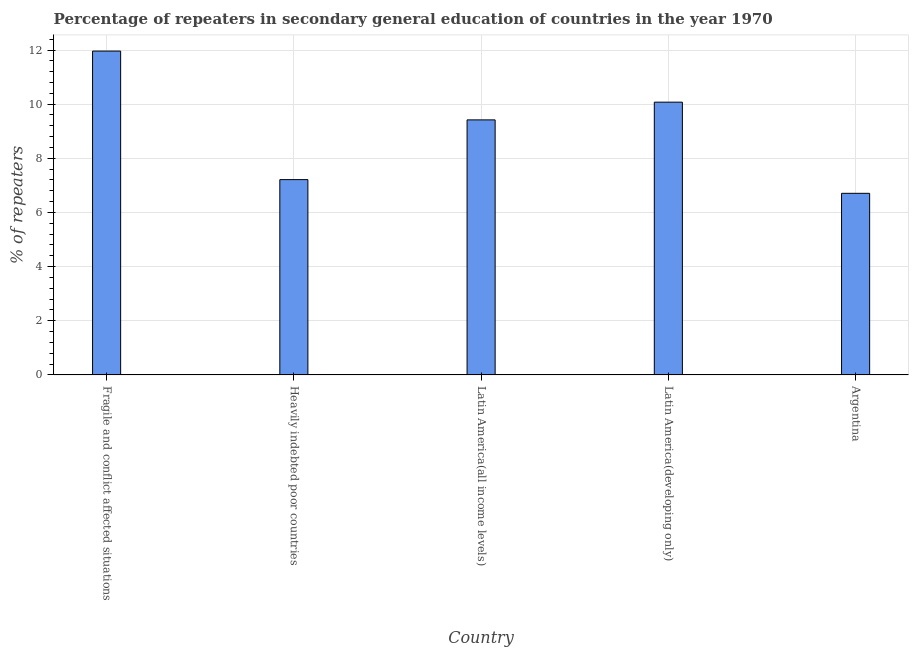Does the graph contain any zero values?
Your response must be concise. No. Does the graph contain grids?
Keep it short and to the point. Yes. What is the title of the graph?
Offer a very short reply. Percentage of repeaters in secondary general education of countries in the year 1970. What is the label or title of the X-axis?
Provide a short and direct response. Country. What is the label or title of the Y-axis?
Offer a terse response. % of repeaters. What is the percentage of repeaters in Latin America(all income levels)?
Offer a very short reply. 9.42. Across all countries, what is the maximum percentage of repeaters?
Your response must be concise. 11.96. Across all countries, what is the minimum percentage of repeaters?
Provide a short and direct response. 6.71. In which country was the percentage of repeaters maximum?
Offer a very short reply. Fragile and conflict affected situations. In which country was the percentage of repeaters minimum?
Your response must be concise. Argentina. What is the sum of the percentage of repeaters?
Your answer should be compact. 45.37. What is the difference between the percentage of repeaters in Latin America(all income levels) and Latin America(developing only)?
Provide a short and direct response. -0.65. What is the average percentage of repeaters per country?
Your answer should be very brief. 9.07. What is the median percentage of repeaters?
Your answer should be compact. 9.42. What is the ratio of the percentage of repeaters in Latin America(all income levels) to that in Latin America(developing only)?
Your answer should be compact. 0.94. Is the percentage of repeaters in Latin America(all income levels) less than that in Latin America(developing only)?
Give a very brief answer. Yes. What is the difference between the highest and the second highest percentage of repeaters?
Your answer should be very brief. 1.89. What is the difference between the highest and the lowest percentage of repeaters?
Offer a very short reply. 5.25. In how many countries, is the percentage of repeaters greater than the average percentage of repeaters taken over all countries?
Provide a short and direct response. 3. What is the difference between two consecutive major ticks on the Y-axis?
Make the answer very short. 2. Are the values on the major ticks of Y-axis written in scientific E-notation?
Ensure brevity in your answer.  No. What is the % of repeaters of Fragile and conflict affected situations?
Ensure brevity in your answer.  11.96. What is the % of repeaters of Heavily indebted poor countries?
Your answer should be very brief. 7.21. What is the % of repeaters of Latin America(all income levels)?
Ensure brevity in your answer.  9.42. What is the % of repeaters of Latin America(developing only)?
Ensure brevity in your answer.  10.07. What is the % of repeaters in Argentina?
Your answer should be compact. 6.71. What is the difference between the % of repeaters in Fragile and conflict affected situations and Heavily indebted poor countries?
Your answer should be very brief. 4.75. What is the difference between the % of repeaters in Fragile and conflict affected situations and Latin America(all income levels)?
Your answer should be very brief. 2.54. What is the difference between the % of repeaters in Fragile and conflict affected situations and Latin America(developing only)?
Offer a terse response. 1.89. What is the difference between the % of repeaters in Fragile and conflict affected situations and Argentina?
Your answer should be compact. 5.25. What is the difference between the % of repeaters in Heavily indebted poor countries and Latin America(all income levels)?
Your response must be concise. -2.21. What is the difference between the % of repeaters in Heavily indebted poor countries and Latin America(developing only)?
Make the answer very short. -2.86. What is the difference between the % of repeaters in Heavily indebted poor countries and Argentina?
Give a very brief answer. 0.51. What is the difference between the % of repeaters in Latin America(all income levels) and Latin America(developing only)?
Provide a succinct answer. -0.65. What is the difference between the % of repeaters in Latin America(all income levels) and Argentina?
Make the answer very short. 2.71. What is the difference between the % of repeaters in Latin America(developing only) and Argentina?
Keep it short and to the point. 3.37. What is the ratio of the % of repeaters in Fragile and conflict affected situations to that in Heavily indebted poor countries?
Your response must be concise. 1.66. What is the ratio of the % of repeaters in Fragile and conflict affected situations to that in Latin America(all income levels)?
Provide a short and direct response. 1.27. What is the ratio of the % of repeaters in Fragile and conflict affected situations to that in Latin America(developing only)?
Your answer should be very brief. 1.19. What is the ratio of the % of repeaters in Fragile and conflict affected situations to that in Argentina?
Ensure brevity in your answer.  1.78. What is the ratio of the % of repeaters in Heavily indebted poor countries to that in Latin America(all income levels)?
Your answer should be very brief. 0.77. What is the ratio of the % of repeaters in Heavily indebted poor countries to that in Latin America(developing only)?
Offer a terse response. 0.72. What is the ratio of the % of repeaters in Heavily indebted poor countries to that in Argentina?
Ensure brevity in your answer.  1.07. What is the ratio of the % of repeaters in Latin America(all income levels) to that in Latin America(developing only)?
Your response must be concise. 0.94. What is the ratio of the % of repeaters in Latin America(all income levels) to that in Argentina?
Offer a very short reply. 1.4. What is the ratio of the % of repeaters in Latin America(developing only) to that in Argentina?
Your answer should be very brief. 1.5. 